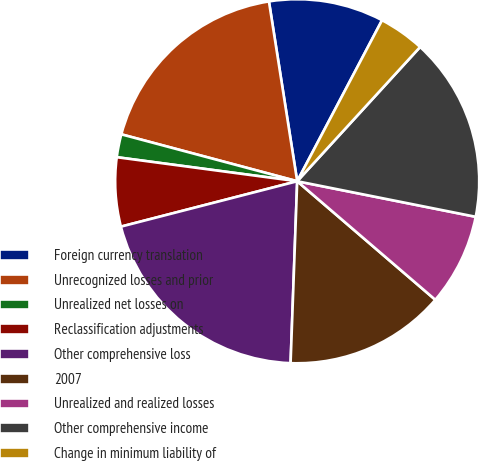Convert chart. <chart><loc_0><loc_0><loc_500><loc_500><pie_chart><fcel>Foreign currency translation<fcel>Unrecognized losses and prior<fcel>Unrealized net losses on<fcel>Reclassification adjustments<fcel>Other comprehensive loss<fcel>2007<fcel>Unrealized and realized losses<fcel>Other comprehensive income<fcel>Change in minimum liability of<nl><fcel>10.2%<fcel>18.37%<fcel>2.04%<fcel>6.12%<fcel>20.41%<fcel>14.29%<fcel>8.16%<fcel>16.33%<fcel>4.08%<nl></chart> 